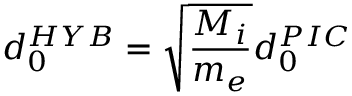<formula> <loc_0><loc_0><loc_500><loc_500>d _ { 0 } ^ { H Y B } = \sqrt { \frac { M _ { i } } { m _ { e } } } d _ { 0 } ^ { P I C }</formula> 